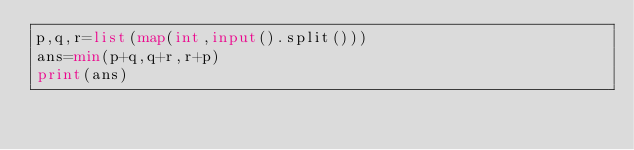Convert code to text. <code><loc_0><loc_0><loc_500><loc_500><_Python_>p,q,r=list(map(int,input().split()))
ans=min(p+q,q+r,r+p)
print(ans)</code> 